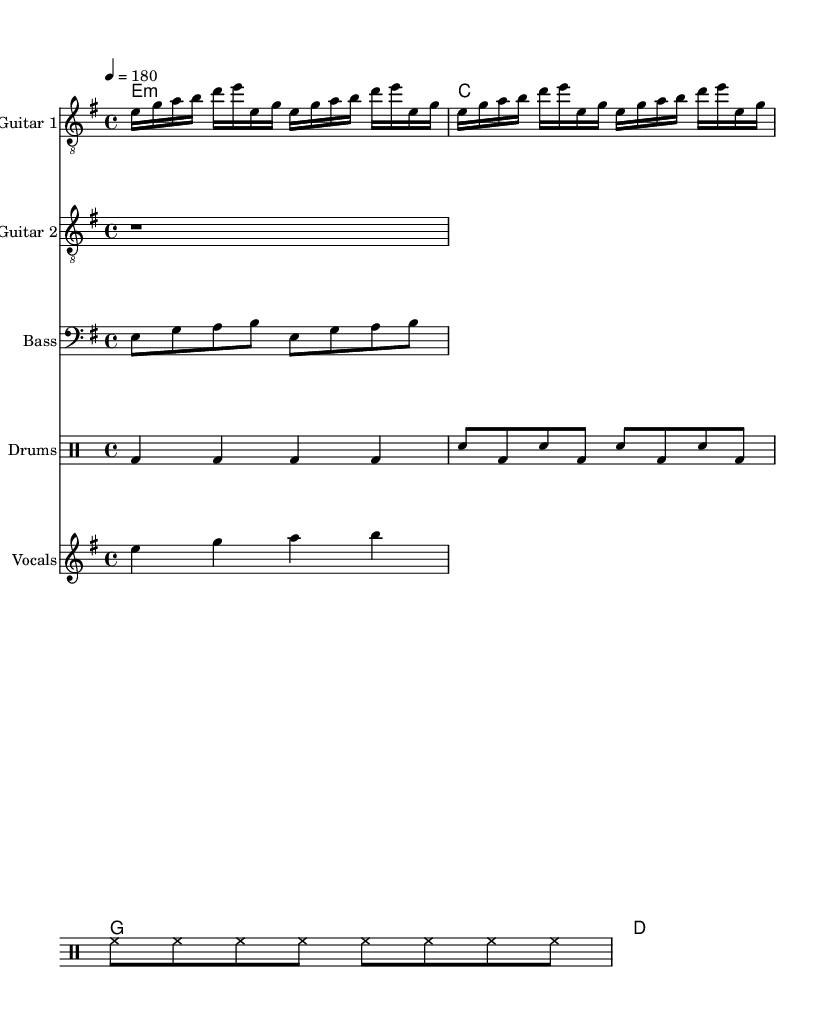what is the key signature of this music? The key signature is E minor, which has one sharp (F sharp). This can be determined by looking at the key signature at the beginning of the score.
Answer: E minor what is the time signature of this music? The time signature is 4/4, which indicates four beats per measure and the quarter note gets one beat. This can be seen at the start of the score where the time signature is notated.
Answer: 4/4 what is the tempo marking of this music? The tempo marking is 180 beats per minute, indicated by the tempo directive at the beginning of the score. This means the music should be played relatively fast.
Answer: 180 how many measures are in the guitar part? The guitar part has eight measures, as counted from the clef and notation within the score. Each measure is separated by vertical lines, making it easy to count.
Answer: 8 how many different instruments are in this score? There are five different instruments: Guitar 1, Guitar 2, Bass, Drums, and Vocals. This can be determined by identifying each staff in the score that is labeled with an instrument name.
Answer: 5 what type of chords are present in the chord chart for guitar? The chords present are minor and major, as indicated by the notations above the guitar parts (e1:m for E minor, c for C major, g for G major, and d for D major).
Answer: minor and major what is the primary theme reflected in the vocal line? The vocal line reflects socially conscious themes, typical of crossover thrash with anarcho-punk influences, which can be inferred from the challenging nature of the lyrical phrases.
Answer: socially conscious themes 